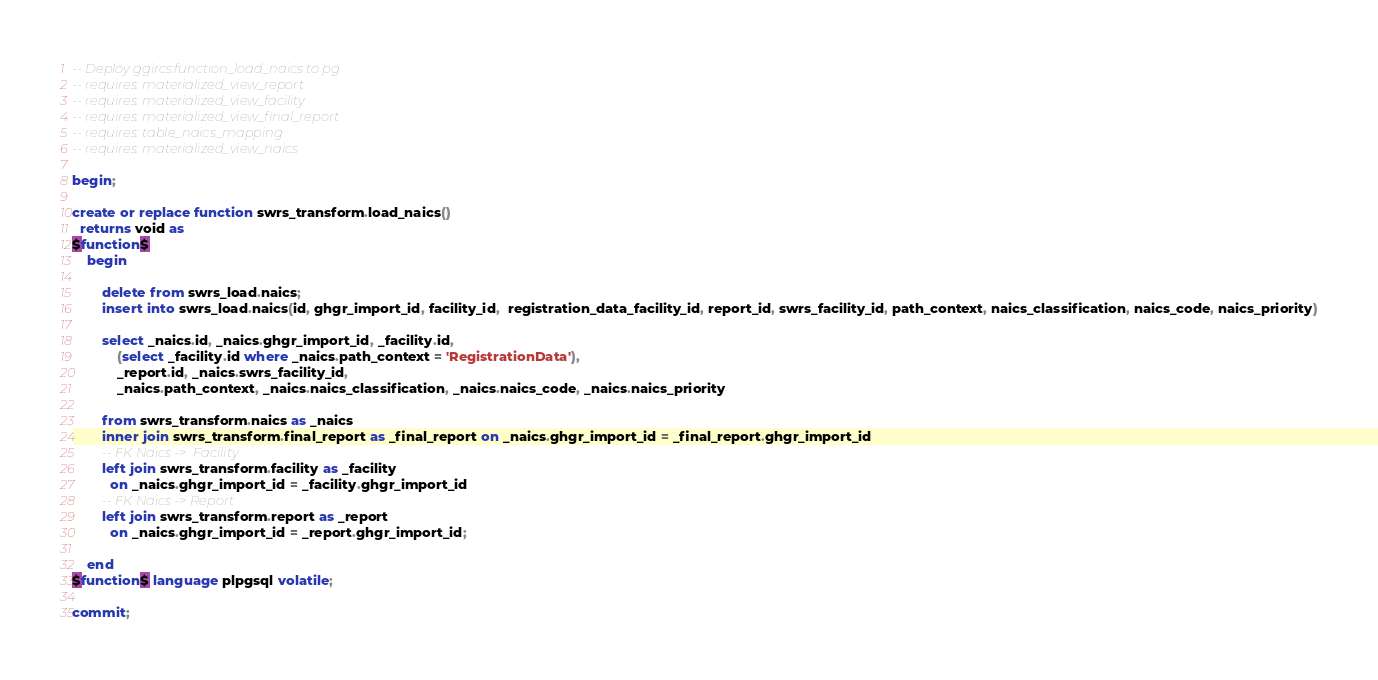<code> <loc_0><loc_0><loc_500><loc_500><_SQL_>-- Deploy ggircs:function_load_naics to pg
-- requires: materialized_view_report
-- requires: materialized_view_facility
-- requires: materialized_view_final_report
-- requires: table_naics_mapping
-- requires: materialized_view_naics

begin;

create or replace function swrs_transform.load_naics()
  returns void as
$function$
    begin

        delete from swrs_load.naics;
        insert into swrs_load.naics(id, ghgr_import_id, facility_id,  registration_data_facility_id, report_id, swrs_facility_id, path_context, naics_classification, naics_code, naics_priority)

        select _naics.id, _naics.ghgr_import_id, _facility.id,
            (select _facility.id where _naics.path_context = 'RegistrationData'),
            _report.id, _naics.swrs_facility_id,
            _naics.path_context, _naics.naics_classification, _naics.naics_code, _naics.naics_priority

        from swrs_transform.naics as _naics
        inner join swrs_transform.final_report as _final_report on _naics.ghgr_import_id = _final_report.ghgr_import_id
        -- FK Naics ->  Facility
        left join swrs_transform.facility as _facility
          on _naics.ghgr_import_id = _facility.ghgr_import_id
        -- FK Naics -> Report
        left join swrs_transform.report as _report
          on _naics.ghgr_import_id = _report.ghgr_import_id;

    end
$function$ language plpgsql volatile;

commit;
</code> 